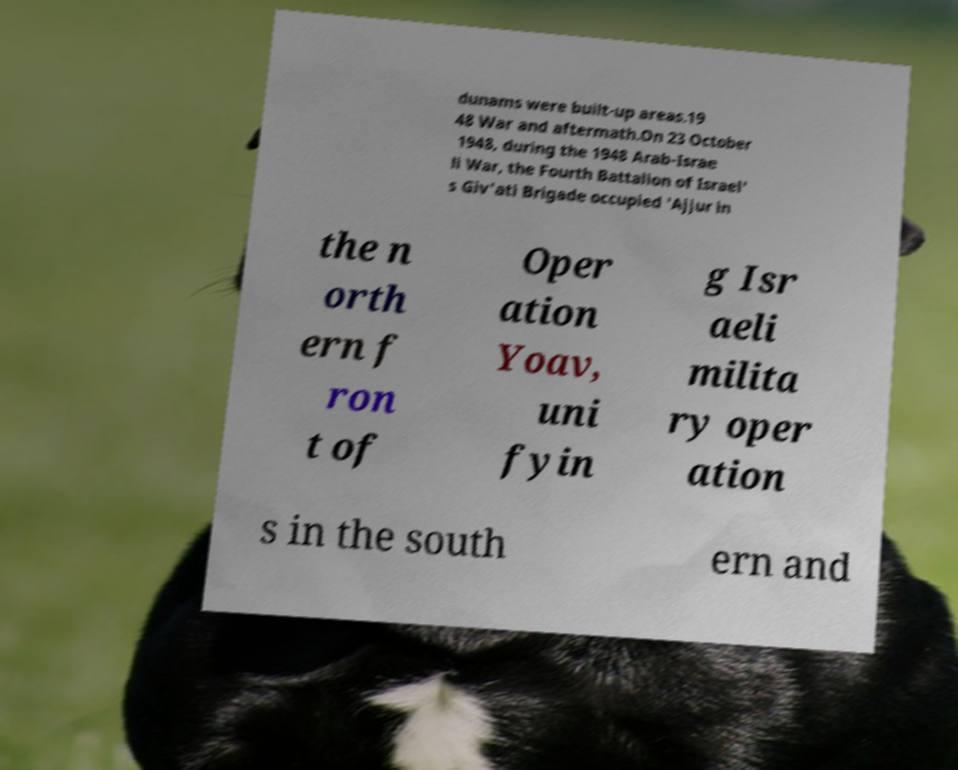What messages or text are displayed in this image? I need them in a readable, typed format. dunams were built-up areas.19 48 War and aftermath.On 23 October 1948, during the 1948 Arab-Israe li War, the Fourth Battalion of Israel' s Giv'ati Brigade occupied 'Ajjur in the n orth ern f ron t of Oper ation Yoav, uni fyin g Isr aeli milita ry oper ation s in the south ern and 